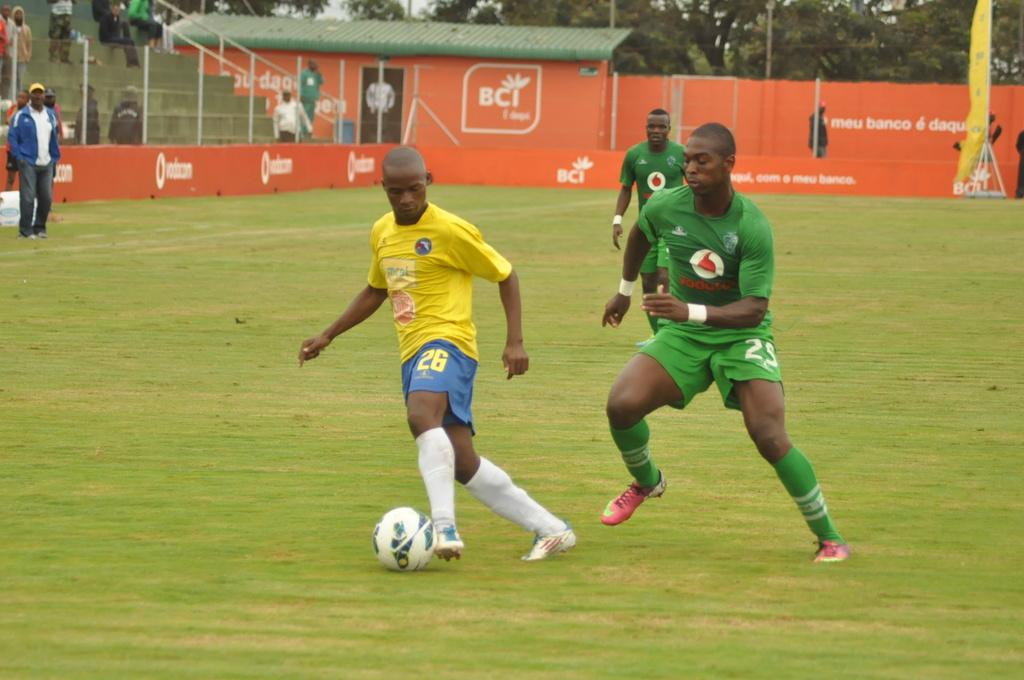What object can be seen in the image? There is a ball in the image. What are the three men doing in the image? The three men are running on the ground. Can you describe the background of the image? There is a group of people standing in the background, along with steps, a door, a wall, and trees. What type of winter sport is being played in the image? There is no indication of a winter sport being played in the image, as there is no snow or ice present. Can you see any bananas or snakes in the image? No, there are no bananas or snakes present in the image. 